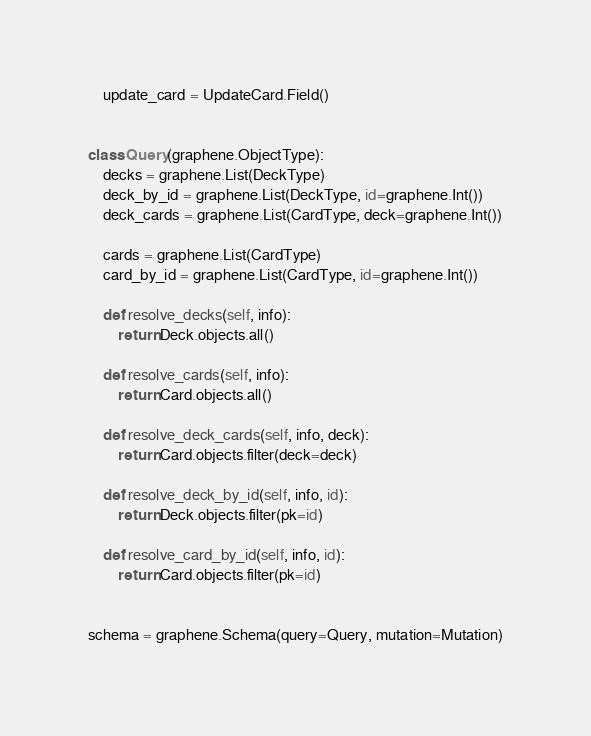Convert code to text. <code><loc_0><loc_0><loc_500><loc_500><_Python_>
    update_card = UpdateCard.Field()


class Query(graphene.ObjectType):
    decks = graphene.List(DeckType)
    deck_by_id = graphene.List(DeckType, id=graphene.Int())
    deck_cards = graphene.List(CardType, deck=graphene.Int())

    cards = graphene.List(CardType)
    card_by_id = graphene.List(CardType, id=graphene.Int())

    def resolve_decks(self, info):
        return Deck.objects.all()

    def resolve_cards(self, info):
        return Card.objects.all()

    def resolve_deck_cards(self, info, deck):
        return Card.objects.filter(deck=deck)

    def resolve_deck_by_id(self, info, id):
        return Deck.objects.filter(pk=id)

    def resolve_card_by_id(self, info, id):
        return Card.objects.filter(pk=id)


schema = graphene.Schema(query=Query, mutation=Mutation)
</code> 